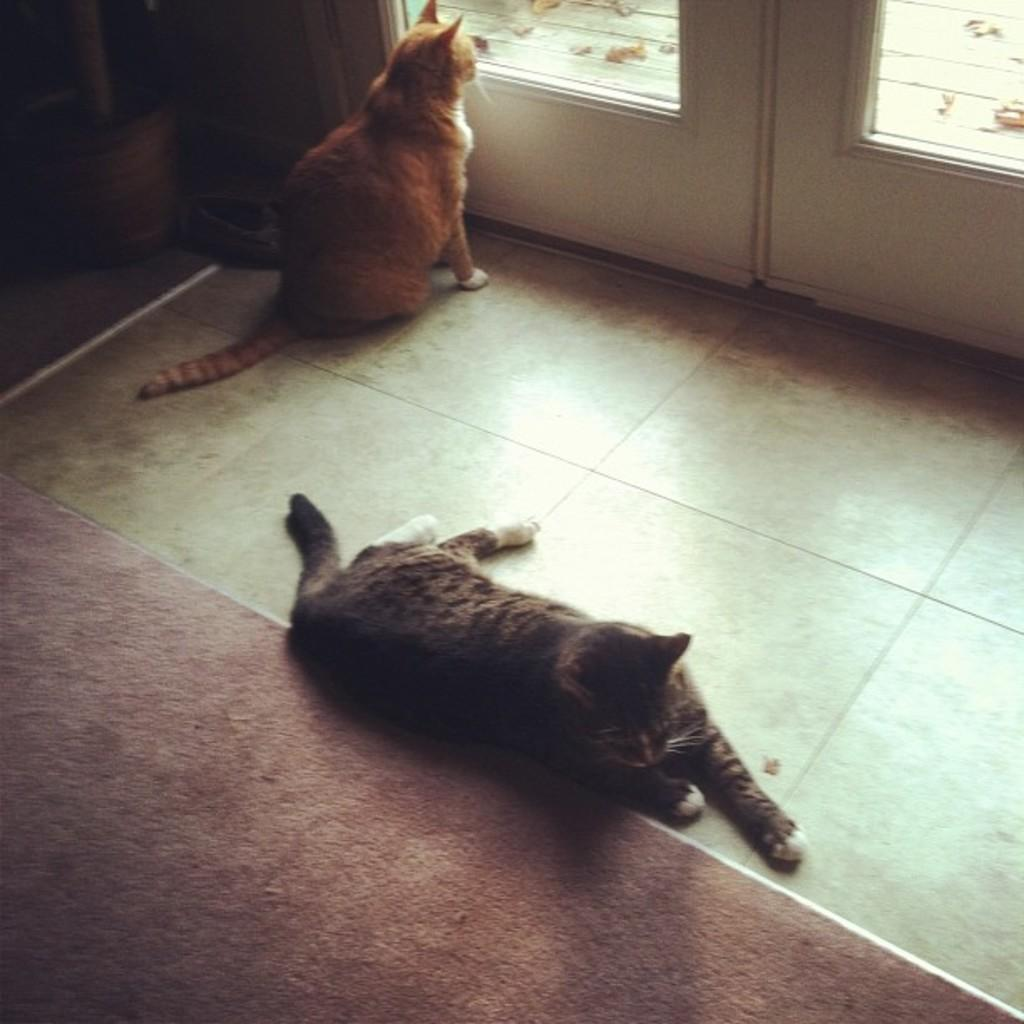How many cats are in the image? There are two cats in the image. What colors are the cats? The cats are in black, white, and brown colors. What can be seen in the background of the image? There is a white door in the image. What is on the floor in the image? There is a floor mat in the image. What is the title of the book the cats are reading in the image? There are no books or reading material present in the image, so there is no title to reference. 